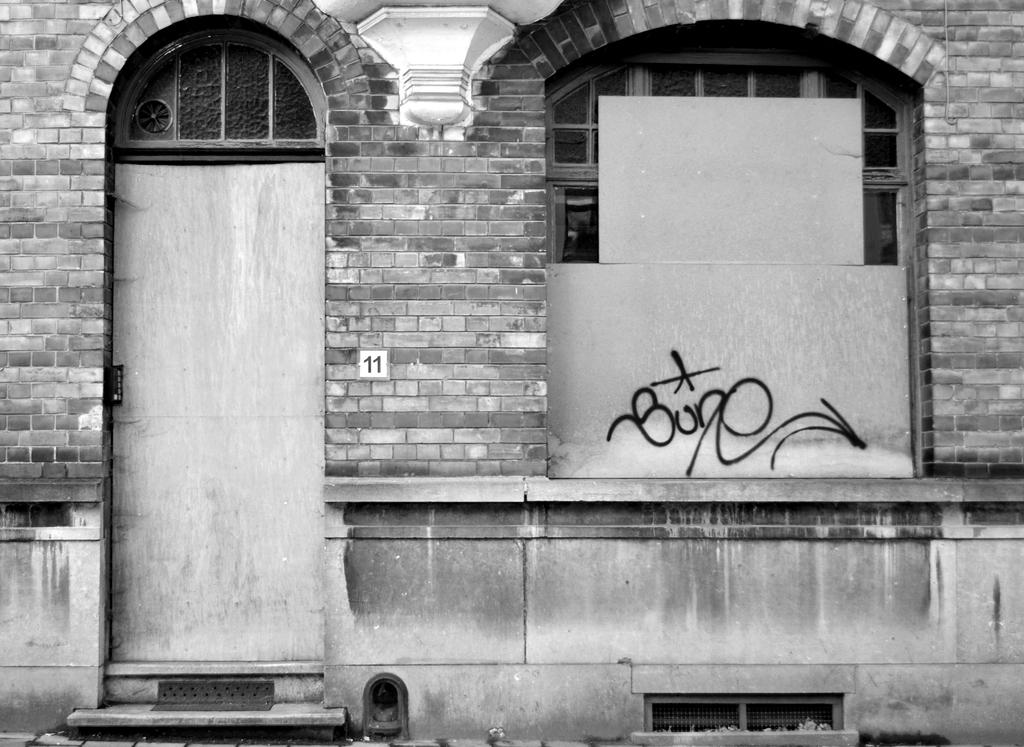What type of structure is visible in the image? There is a building in the image. Where is the door located on the building? The door is on the left side of the building. What other feature can be seen on the building? There is a window on the right side of the building. How many clocks are hanging on the wall inside the building? There is no information about clocks or the interior of the building in the provided facts, so it cannot be determined from the image. 